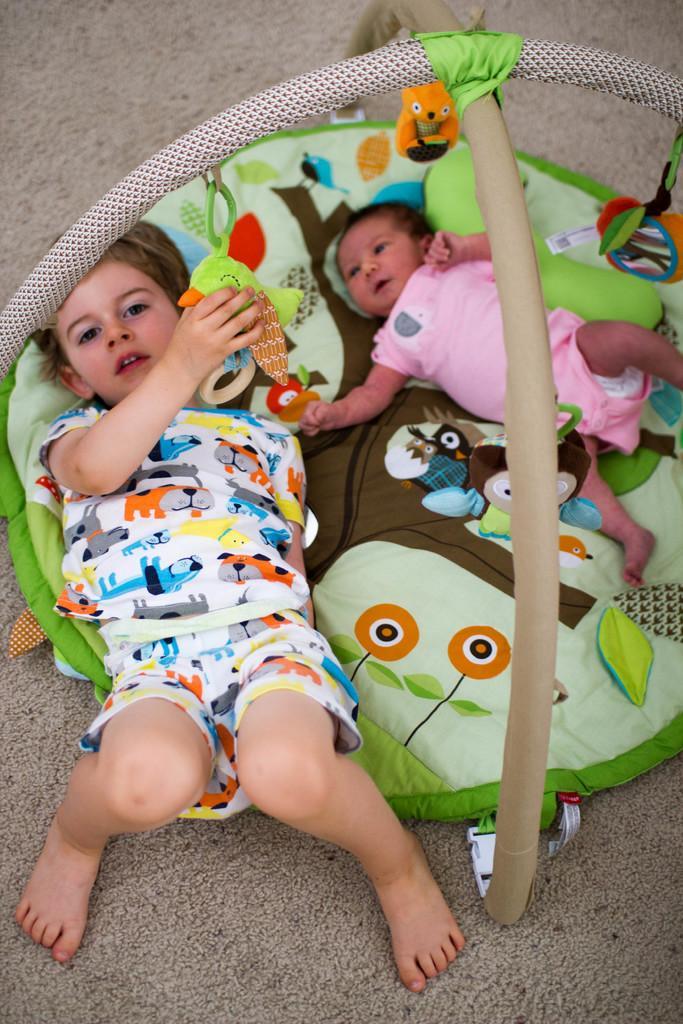How would you summarize this image in a sentence or two? In the image there is a round shape bed with rods. There are few images on the cloth. On the bed there is a baby with pink dress and also there is a kid. They are lying on that bed. 